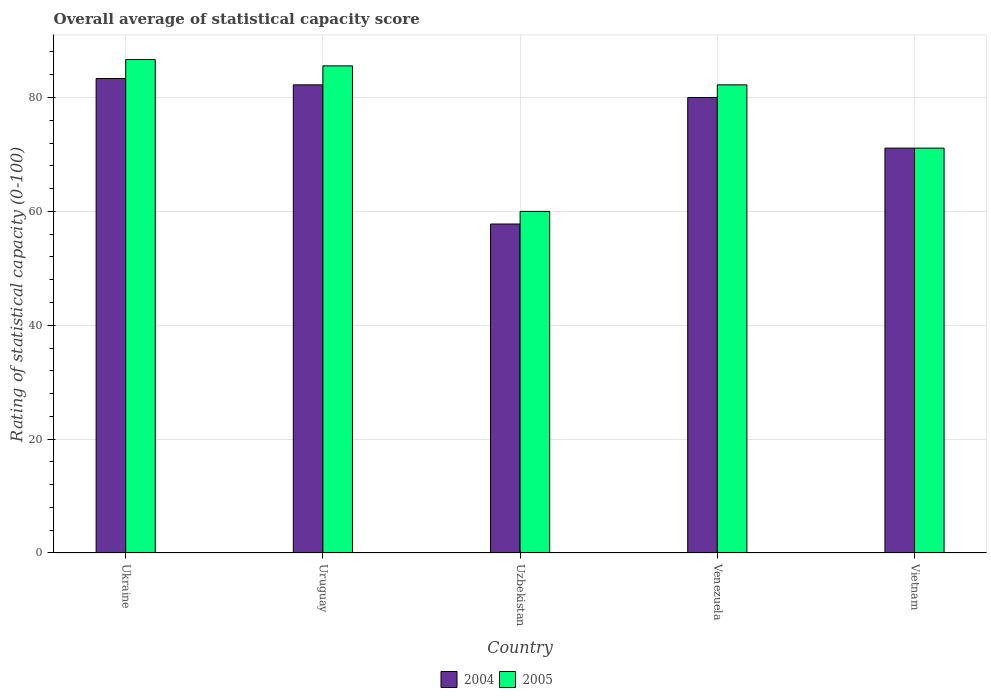How many different coloured bars are there?
Provide a short and direct response. 2. How many groups of bars are there?
Your answer should be compact. 5. Are the number of bars on each tick of the X-axis equal?
Keep it short and to the point. Yes. How many bars are there on the 2nd tick from the right?
Your response must be concise. 2. What is the label of the 2nd group of bars from the left?
Give a very brief answer. Uruguay. What is the rating of statistical capacity in 2004 in Uzbekistan?
Your response must be concise. 57.78. Across all countries, what is the maximum rating of statistical capacity in 2004?
Make the answer very short. 83.33. Across all countries, what is the minimum rating of statistical capacity in 2004?
Your answer should be compact. 57.78. In which country was the rating of statistical capacity in 2004 maximum?
Give a very brief answer. Ukraine. In which country was the rating of statistical capacity in 2004 minimum?
Offer a very short reply. Uzbekistan. What is the total rating of statistical capacity in 2004 in the graph?
Your answer should be very brief. 374.44. What is the difference between the rating of statistical capacity in 2004 in Uruguay and that in Venezuela?
Make the answer very short. 2.22. What is the difference between the rating of statistical capacity in 2005 in Venezuela and the rating of statistical capacity in 2004 in Ukraine?
Provide a short and direct response. -1.11. What is the average rating of statistical capacity in 2005 per country?
Offer a terse response. 77.11. In how many countries, is the rating of statistical capacity in 2004 greater than 24?
Offer a very short reply. 5. What is the ratio of the rating of statistical capacity in 2005 in Uruguay to that in Uzbekistan?
Provide a short and direct response. 1.43. What is the difference between the highest and the second highest rating of statistical capacity in 2005?
Keep it short and to the point. -3.33. What is the difference between the highest and the lowest rating of statistical capacity in 2004?
Keep it short and to the point. 25.56. What does the 1st bar from the right in Venezuela represents?
Give a very brief answer. 2005. How many countries are there in the graph?
Your response must be concise. 5. What is the difference between two consecutive major ticks on the Y-axis?
Keep it short and to the point. 20. Does the graph contain any zero values?
Your answer should be very brief. No. Does the graph contain grids?
Keep it short and to the point. Yes. Where does the legend appear in the graph?
Your response must be concise. Bottom center. How many legend labels are there?
Offer a terse response. 2. How are the legend labels stacked?
Provide a succinct answer. Horizontal. What is the title of the graph?
Offer a very short reply. Overall average of statistical capacity score. Does "1962" appear as one of the legend labels in the graph?
Provide a short and direct response. No. What is the label or title of the X-axis?
Offer a very short reply. Country. What is the label or title of the Y-axis?
Your response must be concise. Rating of statistical capacity (0-100). What is the Rating of statistical capacity (0-100) of 2004 in Ukraine?
Keep it short and to the point. 83.33. What is the Rating of statistical capacity (0-100) in 2005 in Ukraine?
Provide a short and direct response. 86.67. What is the Rating of statistical capacity (0-100) of 2004 in Uruguay?
Give a very brief answer. 82.22. What is the Rating of statistical capacity (0-100) in 2005 in Uruguay?
Give a very brief answer. 85.56. What is the Rating of statistical capacity (0-100) in 2004 in Uzbekistan?
Make the answer very short. 57.78. What is the Rating of statistical capacity (0-100) in 2005 in Uzbekistan?
Give a very brief answer. 60. What is the Rating of statistical capacity (0-100) of 2005 in Venezuela?
Your answer should be compact. 82.22. What is the Rating of statistical capacity (0-100) in 2004 in Vietnam?
Make the answer very short. 71.11. What is the Rating of statistical capacity (0-100) in 2005 in Vietnam?
Your answer should be compact. 71.11. Across all countries, what is the maximum Rating of statistical capacity (0-100) in 2004?
Give a very brief answer. 83.33. Across all countries, what is the maximum Rating of statistical capacity (0-100) of 2005?
Offer a terse response. 86.67. Across all countries, what is the minimum Rating of statistical capacity (0-100) in 2004?
Provide a short and direct response. 57.78. What is the total Rating of statistical capacity (0-100) of 2004 in the graph?
Your response must be concise. 374.44. What is the total Rating of statistical capacity (0-100) in 2005 in the graph?
Provide a short and direct response. 385.56. What is the difference between the Rating of statistical capacity (0-100) of 2005 in Ukraine and that in Uruguay?
Keep it short and to the point. 1.11. What is the difference between the Rating of statistical capacity (0-100) of 2004 in Ukraine and that in Uzbekistan?
Your answer should be very brief. 25.56. What is the difference between the Rating of statistical capacity (0-100) in 2005 in Ukraine and that in Uzbekistan?
Your answer should be very brief. 26.67. What is the difference between the Rating of statistical capacity (0-100) of 2004 in Ukraine and that in Venezuela?
Make the answer very short. 3.33. What is the difference between the Rating of statistical capacity (0-100) in 2005 in Ukraine and that in Venezuela?
Your answer should be compact. 4.44. What is the difference between the Rating of statistical capacity (0-100) of 2004 in Ukraine and that in Vietnam?
Keep it short and to the point. 12.22. What is the difference between the Rating of statistical capacity (0-100) in 2005 in Ukraine and that in Vietnam?
Your answer should be very brief. 15.56. What is the difference between the Rating of statistical capacity (0-100) in 2004 in Uruguay and that in Uzbekistan?
Give a very brief answer. 24.44. What is the difference between the Rating of statistical capacity (0-100) in 2005 in Uruguay and that in Uzbekistan?
Your answer should be very brief. 25.56. What is the difference between the Rating of statistical capacity (0-100) of 2004 in Uruguay and that in Venezuela?
Provide a short and direct response. 2.22. What is the difference between the Rating of statistical capacity (0-100) of 2004 in Uruguay and that in Vietnam?
Your answer should be compact. 11.11. What is the difference between the Rating of statistical capacity (0-100) of 2005 in Uruguay and that in Vietnam?
Your answer should be compact. 14.44. What is the difference between the Rating of statistical capacity (0-100) in 2004 in Uzbekistan and that in Venezuela?
Your response must be concise. -22.22. What is the difference between the Rating of statistical capacity (0-100) of 2005 in Uzbekistan and that in Venezuela?
Offer a terse response. -22.22. What is the difference between the Rating of statistical capacity (0-100) of 2004 in Uzbekistan and that in Vietnam?
Your answer should be very brief. -13.33. What is the difference between the Rating of statistical capacity (0-100) in 2005 in Uzbekistan and that in Vietnam?
Keep it short and to the point. -11.11. What is the difference between the Rating of statistical capacity (0-100) of 2004 in Venezuela and that in Vietnam?
Your response must be concise. 8.89. What is the difference between the Rating of statistical capacity (0-100) of 2005 in Venezuela and that in Vietnam?
Offer a terse response. 11.11. What is the difference between the Rating of statistical capacity (0-100) of 2004 in Ukraine and the Rating of statistical capacity (0-100) of 2005 in Uruguay?
Ensure brevity in your answer.  -2.22. What is the difference between the Rating of statistical capacity (0-100) of 2004 in Ukraine and the Rating of statistical capacity (0-100) of 2005 in Uzbekistan?
Your answer should be compact. 23.33. What is the difference between the Rating of statistical capacity (0-100) of 2004 in Ukraine and the Rating of statistical capacity (0-100) of 2005 in Vietnam?
Make the answer very short. 12.22. What is the difference between the Rating of statistical capacity (0-100) in 2004 in Uruguay and the Rating of statistical capacity (0-100) in 2005 in Uzbekistan?
Your answer should be very brief. 22.22. What is the difference between the Rating of statistical capacity (0-100) of 2004 in Uruguay and the Rating of statistical capacity (0-100) of 2005 in Venezuela?
Keep it short and to the point. 0. What is the difference between the Rating of statistical capacity (0-100) in 2004 in Uruguay and the Rating of statistical capacity (0-100) in 2005 in Vietnam?
Offer a very short reply. 11.11. What is the difference between the Rating of statistical capacity (0-100) in 2004 in Uzbekistan and the Rating of statistical capacity (0-100) in 2005 in Venezuela?
Your answer should be compact. -24.44. What is the difference between the Rating of statistical capacity (0-100) in 2004 in Uzbekistan and the Rating of statistical capacity (0-100) in 2005 in Vietnam?
Your answer should be compact. -13.33. What is the difference between the Rating of statistical capacity (0-100) of 2004 in Venezuela and the Rating of statistical capacity (0-100) of 2005 in Vietnam?
Ensure brevity in your answer.  8.89. What is the average Rating of statistical capacity (0-100) of 2004 per country?
Offer a very short reply. 74.89. What is the average Rating of statistical capacity (0-100) of 2005 per country?
Offer a very short reply. 77.11. What is the difference between the Rating of statistical capacity (0-100) of 2004 and Rating of statistical capacity (0-100) of 2005 in Uzbekistan?
Provide a short and direct response. -2.22. What is the difference between the Rating of statistical capacity (0-100) of 2004 and Rating of statistical capacity (0-100) of 2005 in Venezuela?
Give a very brief answer. -2.22. What is the ratio of the Rating of statistical capacity (0-100) in 2004 in Ukraine to that in Uruguay?
Ensure brevity in your answer.  1.01. What is the ratio of the Rating of statistical capacity (0-100) of 2005 in Ukraine to that in Uruguay?
Offer a terse response. 1.01. What is the ratio of the Rating of statistical capacity (0-100) of 2004 in Ukraine to that in Uzbekistan?
Keep it short and to the point. 1.44. What is the ratio of the Rating of statistical capacity (0-100) in 2005 in Ukraine to that in Uzbekistan?
Provide a short and direct response. 1.44. What is the ratio of the Rating of statistical capacity (0-100) in 2004 in Ukraine to that in Venezuela?
Your answer should be very brief. 1.04. What is the ratio of the Rating of statistical capacity (0-100) of 2005 in Ukraine to that in Venezuela?
Your answer should be compact. 1.05. What is the ratio of the Rating of statistical capacity (0-100) in 2004 in Ukraine to that in Vietnam?
Your answer should be compact. 1.17. What is the ratio of the Rating of statistical capacity (0-100) of 2005 in Ukraine to that in Vietnam?
Provide a succinct answer. 1.22. What is the ratio of the Rating of statistical capacity (0-100) in 2004 in Uruguay to that in Uzbekistan?
Provide a succinct answer. 1.42. What is the ratio of the Rating of statistical capacity (0-100) of 2005 in Uruguay to that in Uzbekistan?
Give a very brief answer. 1.43. What is the ratio of the Rating of statistical capacity (0-100) of 2004 in Uruguay to that in Venezuela?
Your response must be concise. 1.03. What is the ratio of the Rating of statistical capacity (0-100) in 2005 in Uruguay to that in Venezuela?
Make the answer very short. 1.04. What is the ratio of the Rating of statistical capacity (0-100) of 2004 in Uruguay to that in Vietnam?
Offer a very short reply. 1.16. What is the ratio of the Rating of statistical capacity (0-100) of 2005 in Uruguay to that in Vietnam?
Ensure brevity in your answer.  1.2. What is the ratio of the Rating of statistical capacity (0-100) in 2004 in Uzbekistan to that in Venezuela?
Your answer should be compact. 0.72. What is the ratio of the Rating of statistical capacity (0-100) of 2005 in Uzbekistan to that in Venezuela?
Ensure brevity in your answer.  0.73. What is the ratio of the Rating of statistical capacity (0-100) of 2004 in Uzbekistan to that in Vietnam?
Make the answer very short. 0.81. What is the ratio of the Rating of statistical capacity (0-100) in 2005 in Uzbekistan to that in Vietnam?
Your answer should be compact. 0.84. What is the ratio of the Rating of statistical capacity (0-100) of 2005 in Venezuela to that in Vietnam?
Make the answer very short. 1.16. What is the difference between the highest and the lowest Rating of statistical capacity (0-100) of 2004?
Provide a succinct answer. 25.56. What is the difference between the highest and the lowest Rating of statistical capacity (0-100) of 2005?
Give a very brief answer. 26.67. 